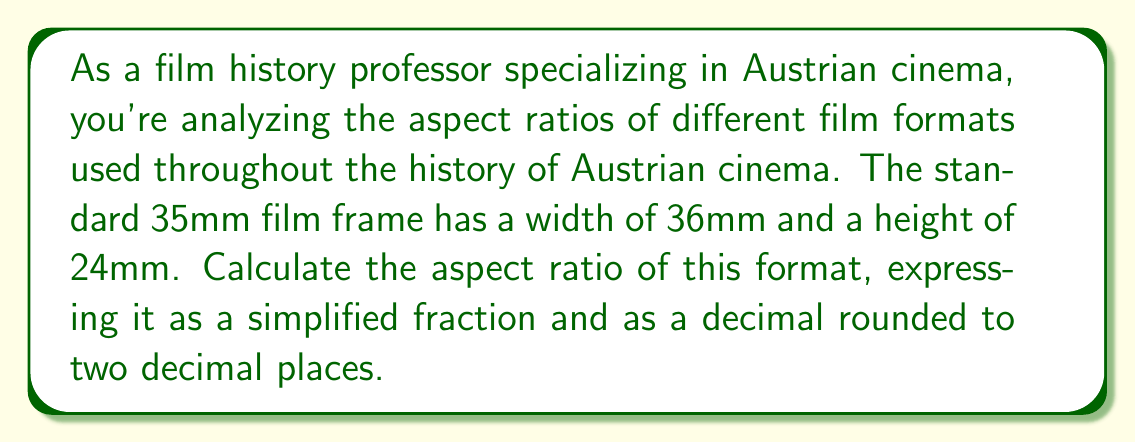Provide a solution to this math problem. To calculate the aspect ratio of a film format, we need to compare the width to the height of the frame. The aspect ratio is expressed as width:height.

Given:
Width of 35mm film frame = 36mm
Height of 35mm film frame = 24mm

Step 1: Set up the ratio of width to height.
Aspect ratio = width : height = 36 : 24

Step 2: Simplify the ratio by dividing both numbers by their greatest common divisor (GCD).
GCD of 36 and 24 is 12.

$\frac{36}{12} : \frac{24}{12} = 3 : 2$

Step 3: Express the ratio as a fraction.
$\frac{3}{2}$

Step 4: Convert the fraction to a decimal.
$\frac{3}{2} = 1.5$

Therefore, the aspect ratio of the standard 35mm film frame is 3:2 as a simplified ratio, $\frac{3}{2}$ as a fraction, and 1.50 when rounded to two decimal places.
Answer: The aspect ratio of the standard 35mm film frame is 3:2, $\frac{3}{2}$, or 1.50. 